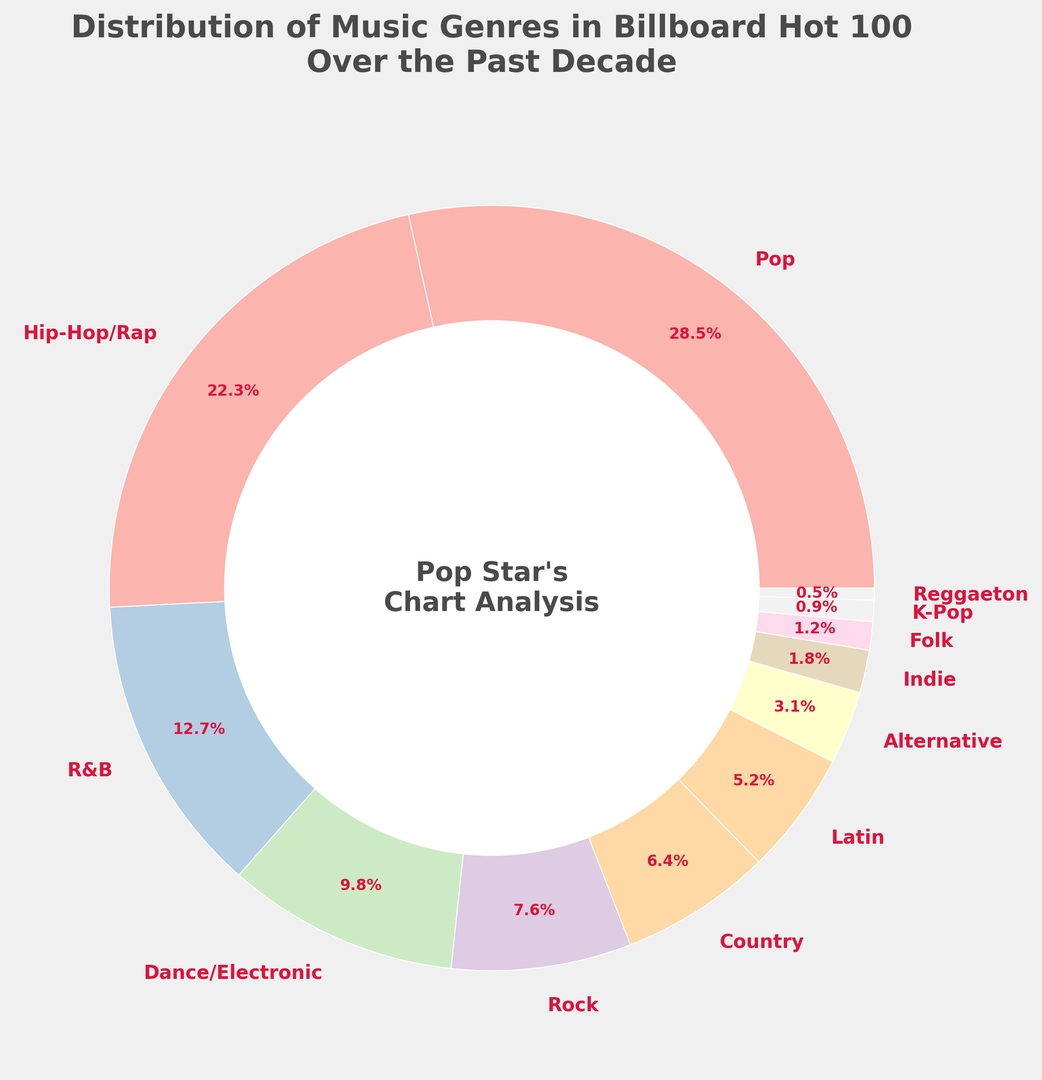What percentage of the Billboard Hot 100 chart does Pop music occupy? Refer to the chart where the wedge labeled as "Pop" displays the percentage segment of 28.5%
Answer: 28.5% Which genre ranks second in terms of percentage on the Billboard Hot 100 chart? From the chart, the second largest wedge is labeled as "Hip-Hop/Rap" with a percentage of 22.3%
Answer: Hip-Hop/Rap How does the percentage of Hip-Hop/Rap compare to the percentage of Pop? The wedge for Hip-Hop/Rap is 22.3%, and the wedge for Pop is 28.5%. Pop is greater than Hip-Hop/Rap by 28.5% - 22.3% = 6.2%
Answer: Pop is 6.2% greater Compare the total percentage of Rock, Country, Latin, and Alternative music combined to Hip-Hop/Rap. Summing up Rock (7.6%), Country (6.4%), Latin (5.2%), and Alternative (3.1%) gives 7.6 + 6.4 + 5.2 + 3.1 = 22.3%. This is equal to the percentage for Hip-Hop/Rap at 22.3%
Answer: Equal What is the combined percentage of genres that occupy less than 2% each in the Billboard Hot 100 chart? The genres with less than 2% are Indie (1.8%), Folk (1.2%), K-Pop (0.9%), and Reggaeton (0.5%). Summing these gives 1.8 + 1.2 + 0.9 + 0.5 = 4.4%
Answer: 4.4% Which genre has the smallest percentage on the Billboard Hot 100 chart, and what is that percentage? The smallest wedge in the chart is labeled as "Reggaeton" with a percentage of 0.5%
Answer: Reggaeton, 0.5% What is the difference between the total percentages of Pop, Hip-Hop/Rap, and R&B combined and the total percentages of Country, Latin, and Rock combined? Sum Pop (28.5%), Hip-Hop/Rap (22.3%), and R&B (12.7%) gives 28.5 + 22.3 + 12.7 = 63.5%. Sum Country (6.4%), Latin (5.2%), and Rock (7.6%) gives 6.4 + 5.2 + 7.6 = 19.2%. The difference is 63.5% - 19.2% = 44.3%
Answer: 44.3% What visual feature highlights Pop music in the ring chart? The wedge representing Pop music is the largest segment, distinctly wider compared to other wedges, visually indicating it has the highest percentage
Answer: Largest wedge 